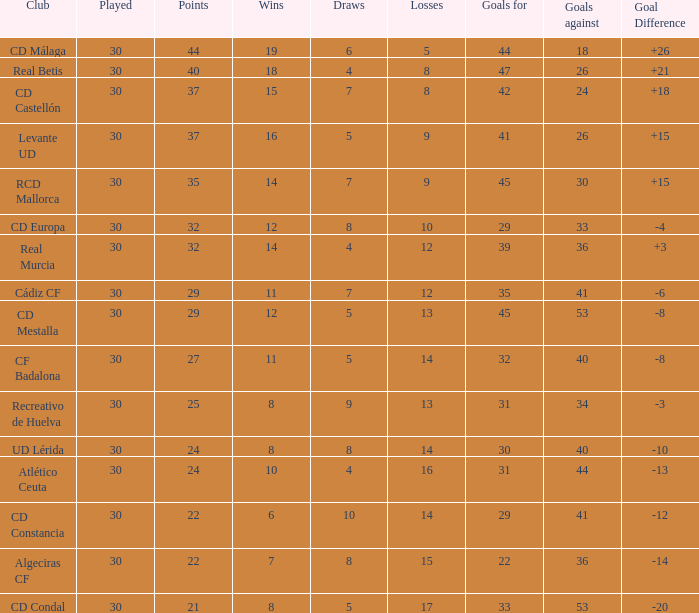What is the wins number when the points were smaller than 27, and goals against was 41? 6.0. 